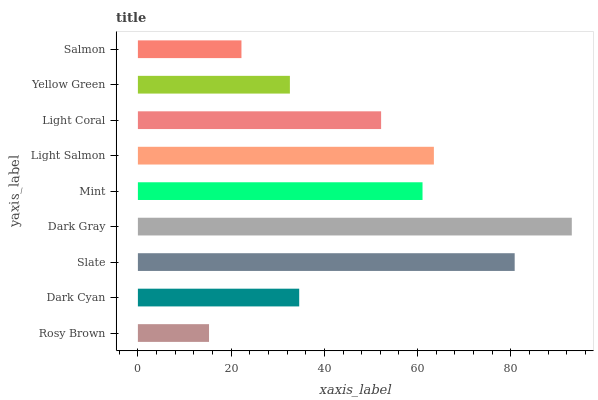Is Rosy Brown the minimum?
Answer yes or no. Yes. Is Dark Gray the maximum?
Answer yes or no. Yes. Is Dark Cyan the minimum?
Answer yes or no. No. Is Dark Cyan the maximum?
Answer yes or no. No. Is Dark Cyan greater than Rosy Brown?
Answer yes or no. Yes. Is Rosy Brown less than Dark Cyan?
Answer yes or no. Yes. Is Rosy Brown greater than Dark Cyan?
Answer yes or no. No. Is Dark Cyan less than Rosy Brown?
Answer yes or no. No. Is Light Coral the high median?
Answer yes or no. Yes. Is Light Coral the low median?
Answer yes or no. Yes. Is Rosy Brown the high median?
Answer yes or no. No. Is Mint the low median?
Answer yes or no. No. 